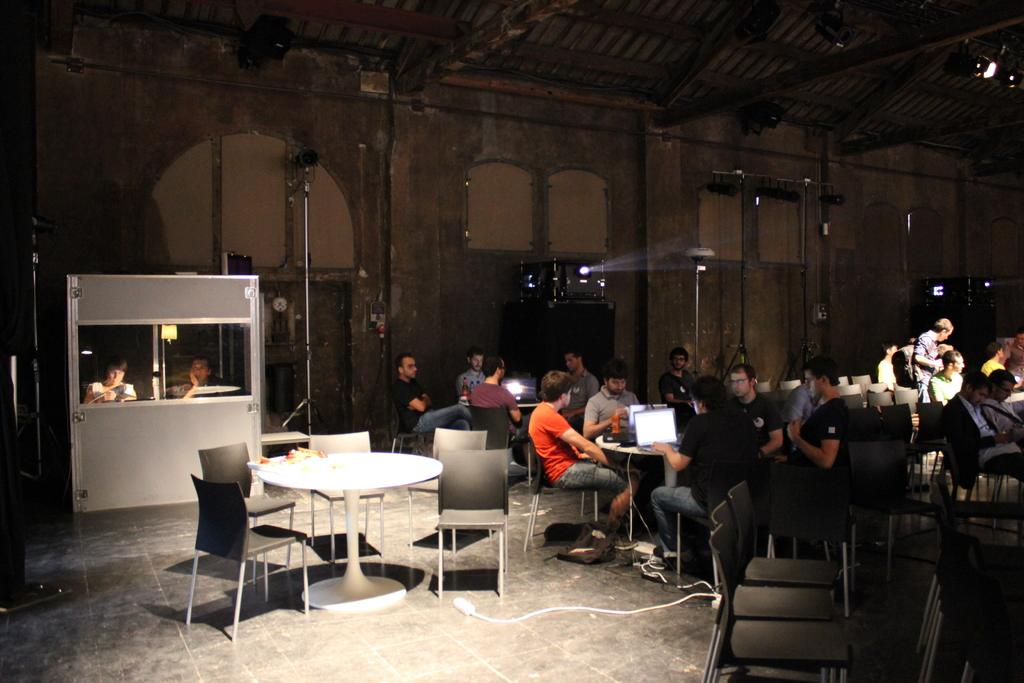What type of structure can be seen in the image? There is a wall in the image. What device is present for displaying visuals? There is a projector in the image. How are the people in the image positioned? There are people sitting on chairs in the image. What type of furniture is present in the image? There are tables in the image. What electronic devices are placed on the tables? There are laptops on the tables. What type of stamp can be seen on the wall in the image? There is no stamp present on the wall in the image. What type of pleasure can be seen being experienced by the people in the image? The image does not depict any specific pleasure being experienced by the people; they are simply sitting on chairs. 